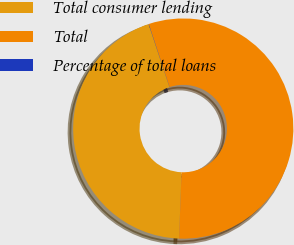Convert chart to OTSL. <chart><loc_0><loc_0><loc_500><loc_500><pie_chart><fcel>Total consumer lending<fcel>Total<fcel>Percentage of total loans<nl><fcel>44.29%<fcel>55.68%<fcel>0.03%<nl></chart> 